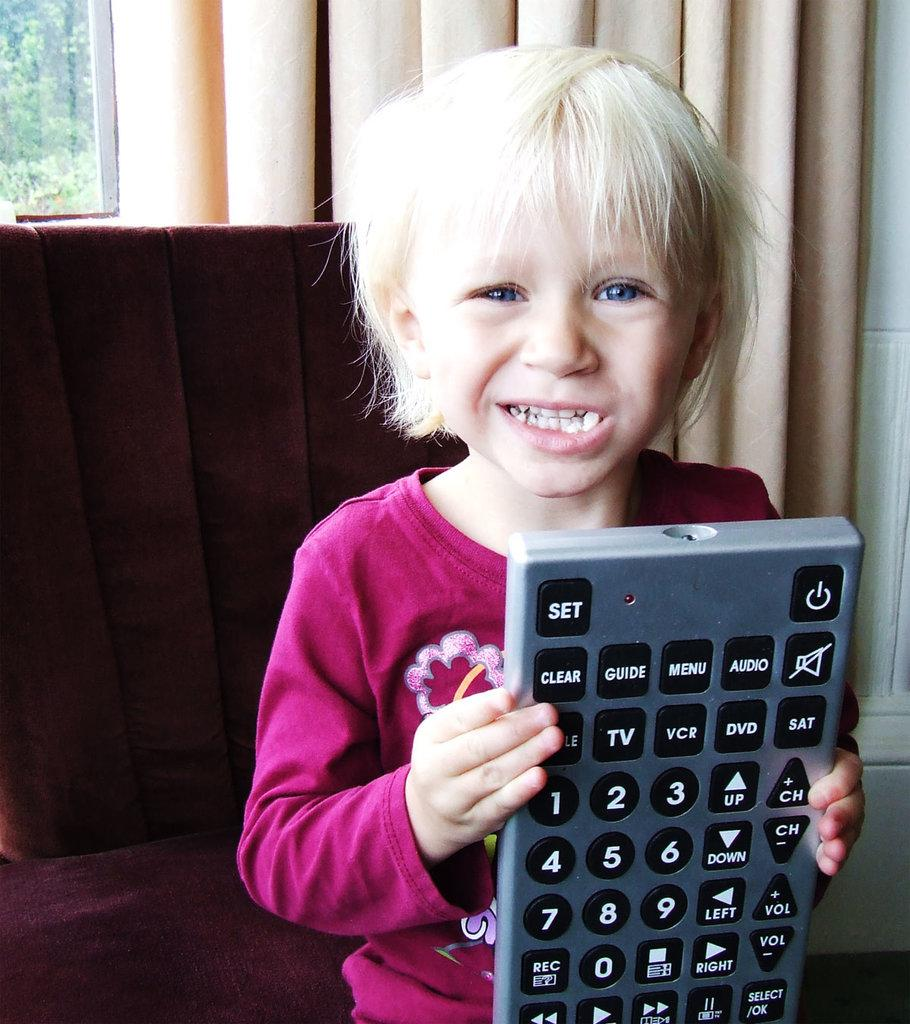<image>
Share a concise interpretation of the image provided. Girl holding a giant controller that says SET on the top left. 